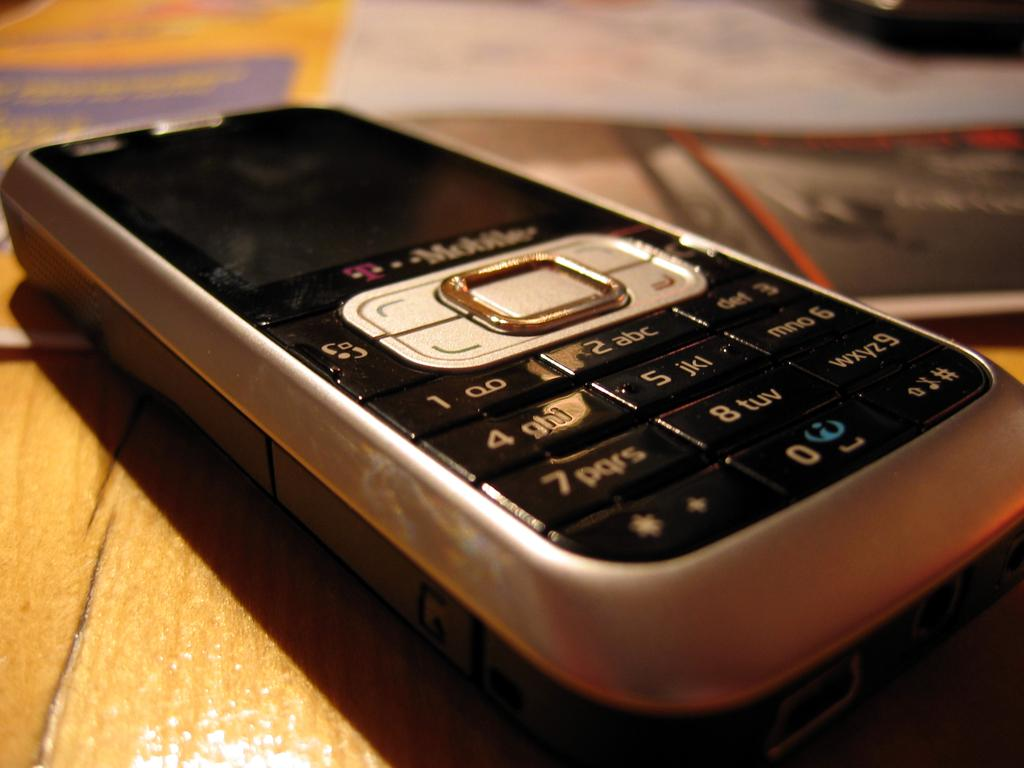What electronic device is visible in the image? There is a mobile phone in the image. Can you describe the background of the image? The background of the image is blurry. What type of surface is at the bottom of the image? The bottom of the image appears to be a wooden surface. What type of blade is being used on the person's skin in the image? There is no blade or person present in the image; it only features a mobile phone on a wooden surface with a blurry background. 